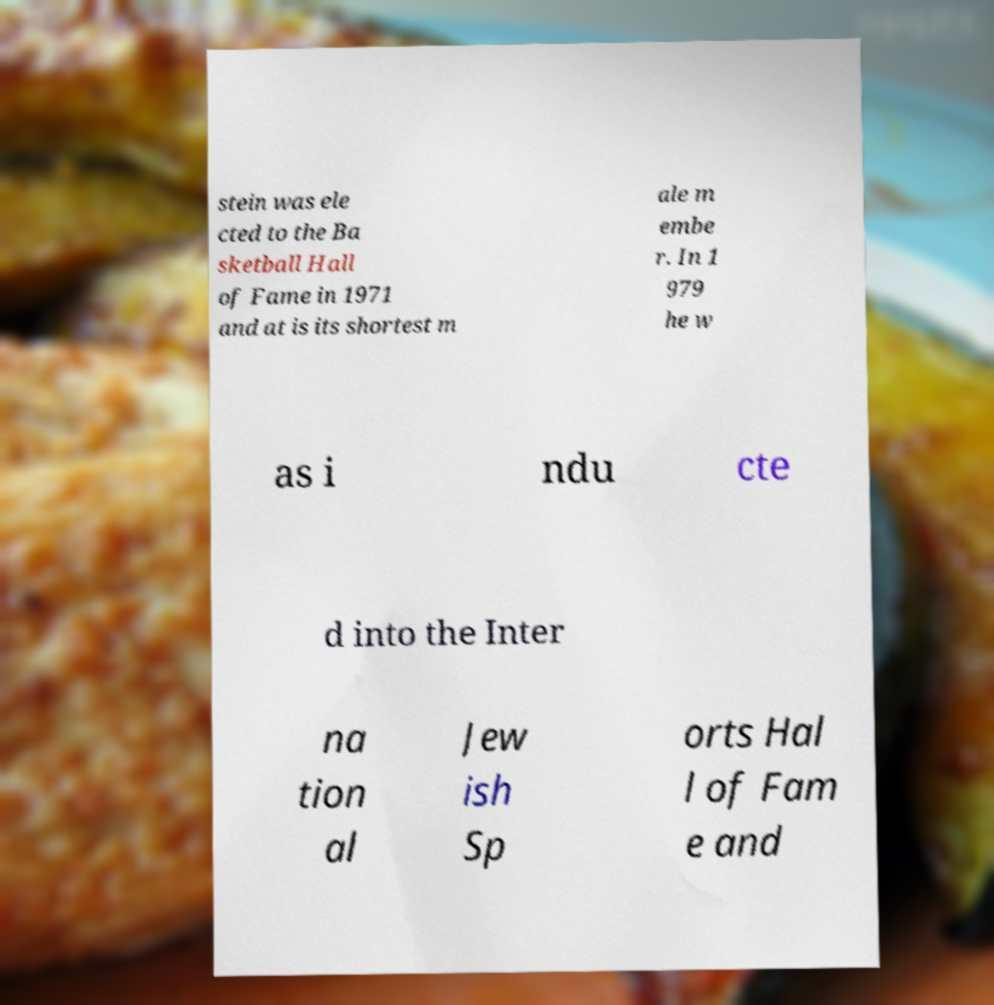Can you read and provide the text displayed in the image?This photo seems to have some interesting text. Can you extract and type it out for me? stein was ele cted to the Ba sketball Hall of Fame in 1971 and at is its shortest m ale m embe r. In 1 979 he w as i ndu cte d into the Inter na tion al Jew ish Sp orts Hal l of Fam e and 